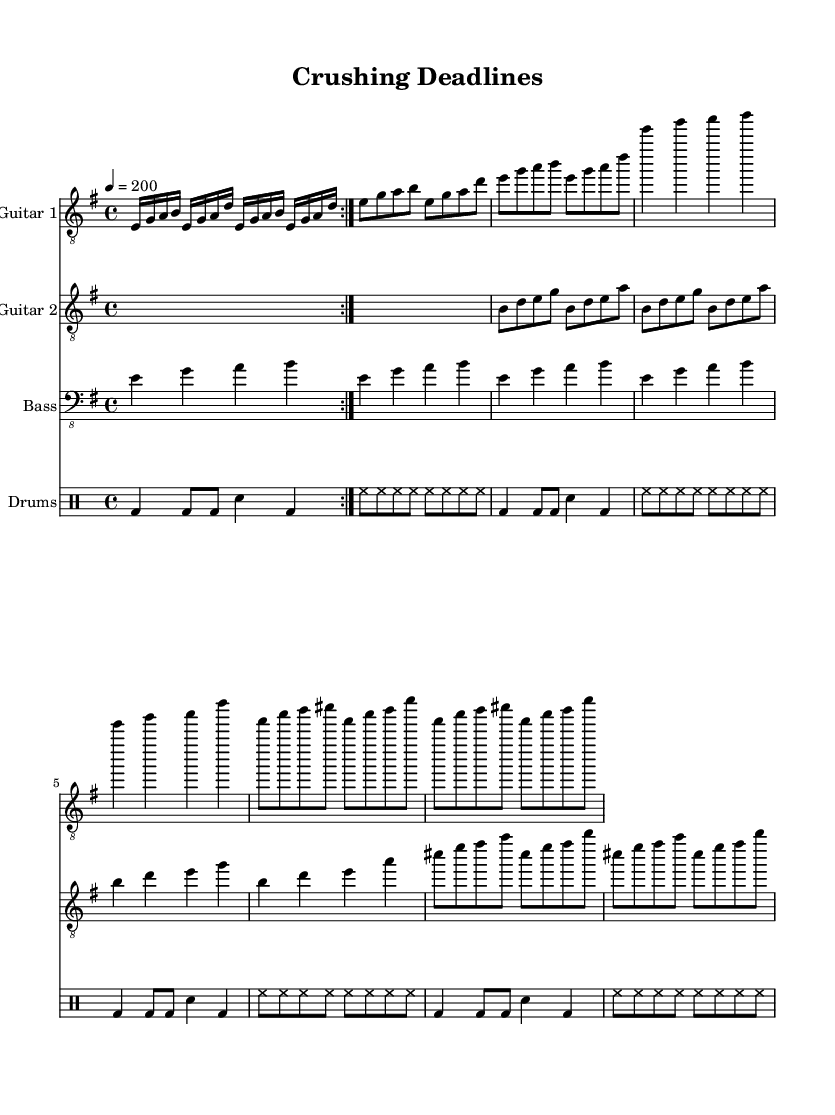What is the key signature of this music? The key signature is E minor, which has one sharp (F#) and is indicated at the beginning of the staff.
Answer: E minor What is the time signature of this music? The time signature is 4/4, which is shown at the beginning of the score indicating that there are four beats in each measure.
Answer: 4/4 What is the tempo marking of this piece? The tempo marking is 200 beats per minute, which is specified in a standard format under the global settings section of the music score.
Answer: 200 How many measures are in the intro section? The intro section consists of 2 measures as indicated by the repeat sign in the main riff section. Each measure contains 8 sixteenth notes broken down into two beats.
Answer: 2 Which instrument plays the bridge section? The bridge section is played by both guitars with distinct parts, but since no specific instrument is alone indicated, it generally refers to the guitars and bass doing a harmonic progression alongside the drums.
Answer: Guitars How many times is the bass line repeated in the score? The bass line is repeated 4 times as indicated by the repeat unfold command at the beginning of the bass guitar part section.
Answer: 4 What is the significance of the term "tacet" in the intro? The term "tacet" means that the instrument does not play during that section, which in this context refers to Guitar 2 not playing during the intro.
Answer: Tacet 